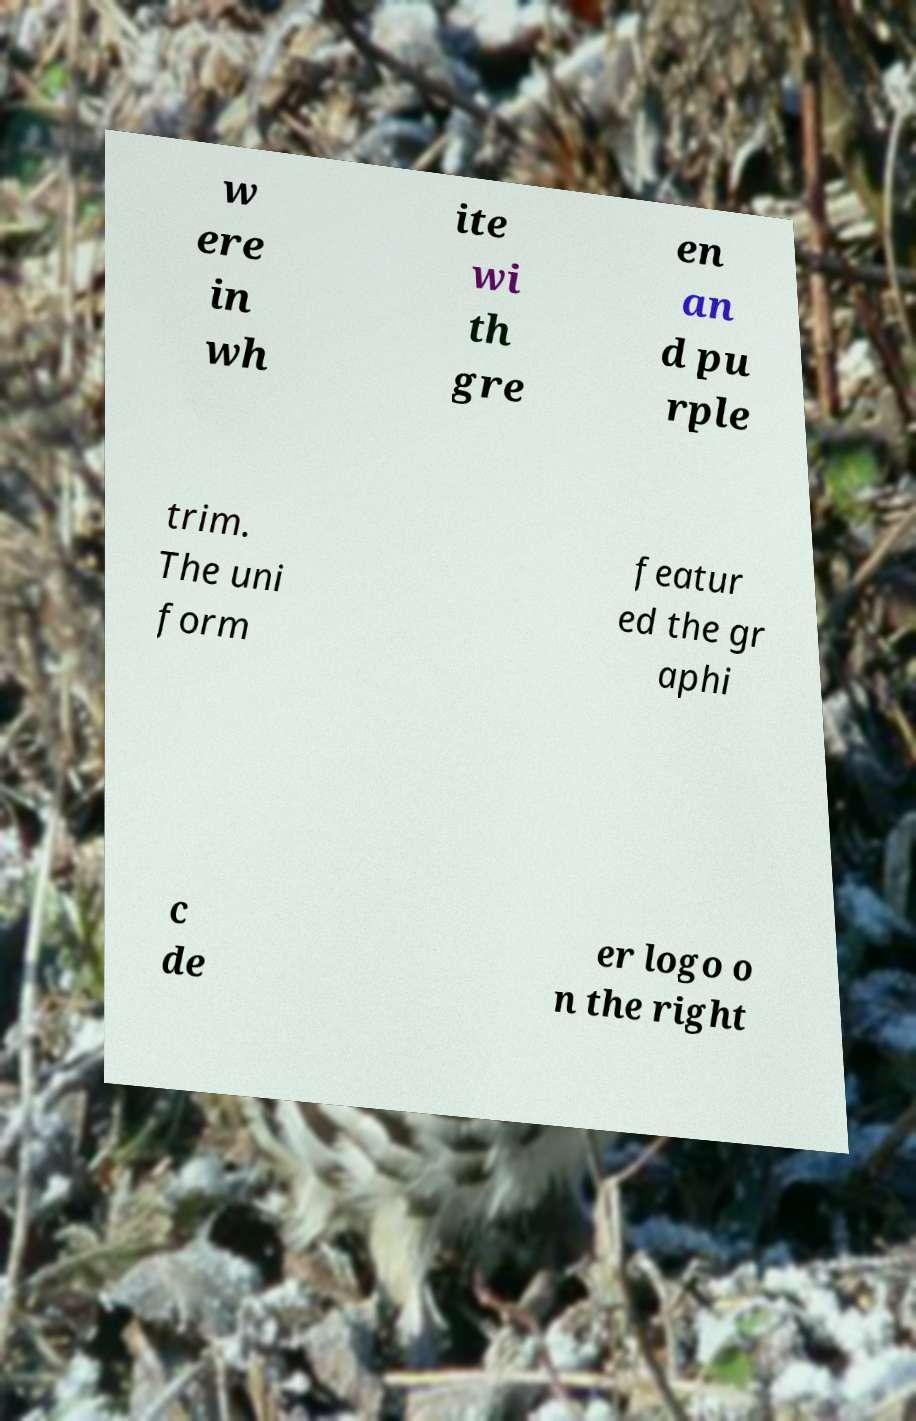Can you read and provide the text displayed in the image?This photo seems to have some interesting text. Can you extract and type it out for me? w ere in wh ite wi th gre en an d pu rple trim. The uni form featur ed the gr aphi c de er logo o n the right 